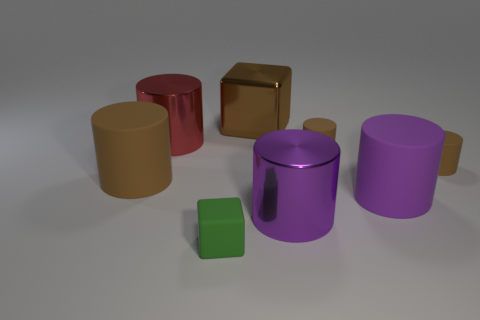There is a brown matte thing that is left of the tiny green rubber cube; is it the same shape as the tiny green rubber object?
Your answer should be very brief. No. There is a tiny thing that is on the left side of the big brown cube; what color is it?
Your answer should be very brief. Green. How many blocks are either large gray matte objects or small brown matte objects?
Your response must be concise. 0. What size is the block that is in front of the large brown thing that is in front of the red cylinder?
Your answer should be compact. Small. Do the tiny rubber cube and the big rubber object that is on the right side of the tiny matte cube have the same color?
Provide a succinct answer. No. What number of things are left of the purple metallic object?
Provide a short and direct response. 4. Is the number of tiny brown rubber spheres less than the number of purple matte objects?
Ensure brevity in your answer.  Yes. There is a metal object that is both behind the big brown rubber object and on the right side of the big red shiny cylinder; what is its size?
Your answer should be very brief. Large. Does the block that is in front of the large brown rubber cylinder have the same color as the shiny cube?
Make the answer very short. No. Is the number of green things that are behind the brown metallic object less than the number of small blue metallic balls?
Ensure brevity in your answer.  No. 